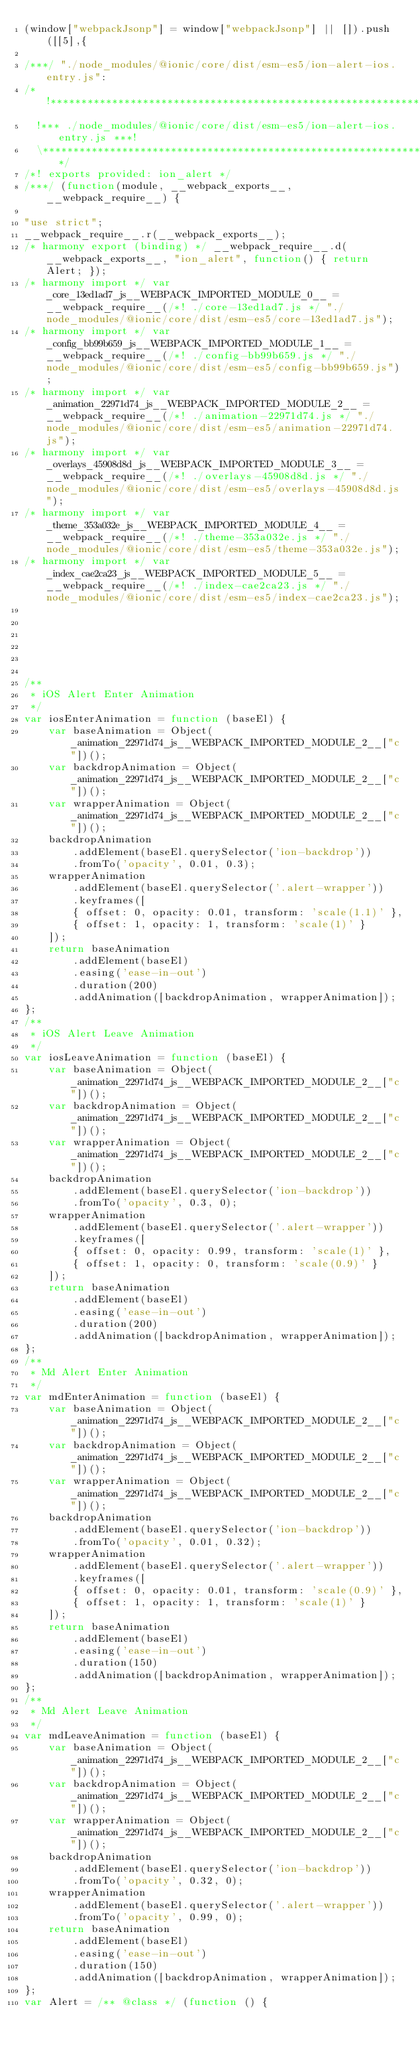<code> <loc_0><loc_0><loc_500><loc_500><_JavaScript_>(window["webpackJsonp"] = window["webpackJsonp"] || []).push([[5],{

/***/ "./node_modules/@ionic/core/dist/esm-es5/ion-alert-ios.entry.js":
/*!**********************************************************************!*\
  !*** ./node_modules/@ionic/core/dist/esm-es5/ion-alert-ios.entry.js ***!
  \**********************************************************************/
/*! exports provided: ion_alert */
/***/ (function(module, __webpack_exports__, __webpack_require__) {

"use strict";
__webpack_require__.r(__webpack_exports__);
/* harmony export (binding) */ __webpack_require__.d(__webpack_exports__, "ion_alert", function() { return Alert; });
/* harmony import */ var _core_13ed1ad7_js__WEBPACK_IMPORTED_MODULE_0__ = __webpack_require__(/*! ./core-13ed1ad7.js */ "./node_modules/@ionic/core/dist/esm-es5/core-13ed1ad7.js");
/* harmony import */ var _config_bb99b659_js__WEBPACK_IMPORTED_MODULE_1__ = __webpack_require__(/*! ./config-bb99b659.js */ "./node_modules/@ionic/core/dist/esm-es5/config-bb99b659.js");
/* harmony import */ var _animation_22971d74_js__WEBPACK_IMPORTED_MODULE_2__ = __webpack_require__(/*! ./animation-22971d74.js */ "./node_modules/@ionic/core/dist/esm-es5/animation-22971d74.js");
/* harmony import */ var _overlays_45908d8d_js__WEBPACK_IMPORTED_MODULE_3__ = __webpack_require__(/*! ./overlays-45908d8d.js */ "./node_modules/@ionic/core/dist/esm-es5/overlays-45908d8d.js");
/* harmony import */ var _theme_353a032e_js__WEBPACK_IMPORTED_MODULE_4__ = __webpack_require__(/*! ./theme-353a032e.js */ "./node_modules/@ionic/core/dist/esm-es5/theme-353a032e.js");
/* harmony import */ var _index_cae2ca23_js__WEBPACK_IMPORTED_MODULE_5__ = __webpack_require__(/*! ./index-cae2ca23.js */ "./node_modules/@ionic/core/dist/esm-es5/index-cae2ca23.js");






/**
 * iOS Alert Enter Animation
 */
var iosEnterAnimation = function (baseEl) {
    var baseAnimation = Object(_animation_22971d74_js__WEBPACK_IMPORTED_MODULE_2__["c"])();
    var backdropAnimation = Object(_animation_22971d74_js__WEBPACK_IMPORTED_MODULE_2__["c"])();
    var wrapperAnimation = Object(_animation_22971d74_js__WEBPACK_IMPORTED_MODULE_2__["c"])();
    backdropAnimation
        .addElement(baseEl.querySelector('ion-backdrop'))
        .fromTo('opacity', 0.01, 0.3);
    wrapperAnimation
        .addElement(baseEl.querySelector('.alert-wrapper'))
        .keyframes([
        { offset: 0, opacity: 0.01, transform: 'scale(1.1)' },
        { offset: 1, opacity: 1, transform: 'scale(1)' }
    ]);
    return baseAnimation
        .addElement(baseEl)
        .easing('ease-in-out')
        .duration(200)
        .addAnimation([backdropAnimation, wrapperAnimation]);
};
/**
 * iOS Alert Leave Animation
 */
var iosLeaveAnimation = function (baseEl) {
    var baseAnimation = Object(_animation_22971d74_js__WEBPACK_IMPORTED_MODULE_2__["c"])();
    var backdropAnimation = Object(_animation_22971d74_js__WEBPACK_IMPORTED_MODULE_2__["c"])();
    var wrapperAnimation = Object(_animation_22971d74_js__WEBPACK_IMPORTED_MODULE_2__["c"])();
    backdropAnimation
        .addElement(baseEl.querySelector('ion-backdrop'))
        .fromTo('opacity', 0.3, 0);
    wrapperAnimation
        .addElement(baseEl.querySelector('.alert-wrapper'))
        .keyframes([
        { offset: 0, opacity: 0.99, transform: 'scale(1)' },
        { offset: 1, opacity: 0, transform: 'scale(0.9)' }
    ]);
    return baseAnimation
        .addElement(baseEl)
        .easing('ease-in-out')
        .duration(200)
        .addAnimation([backdropAnimation, wrapperAnimation]);
};
/**
 * Md Alert Enter Animation
 */
var mdEnterAnimation = function (baseEl) {
    var baseAnimation = Object(_animation_22971d74_js__WEBPACK_IMPORTED_MODULE_2__["c"])();
    var backdropAnimation = Object(_animation_22971d74_js__WEBPACK_IMPORTED_MODULE_2__["c"])();
    var wrapperAnimation = Object(_animation_22971d74_js__WEBPACK_IMPORTED_MODULE_2__["c"])();
    backdropAnimation
        .addElement(baseEl.querySelector('ion-backdrop'))
        .fromTo('opacity', 0.01, 0.32);
    wrapperAnimation
        .addElement(baseEl.querySelector('.alert-wrapper'))
        .keyframes([
        { offset: 0, opacity: 0.01, transform: 'scale(0.9)' },
        { offset: 1, opacity: 1, transform: 'scale(1)' }
    ]);
    return baseAnimation
        .addElement(baseEl)
        .easing('ease-in-out')
        .duration(150)
        .addAnimation([backdropAnimation, wrapperAnimation]);
};
/**
 * Md Alert Leave Animation
 */
var mdLeaveAnimation = function (baseEl) {
    var baseAnimation = Object(_animation_22971d74_js__WEBPACK_IMPORTED_MODULE_2__["c"])();
    var backdropAnimation = Object(_animation_22971d74_js__WEBPACK_IMPORTED_MODULE_2__["c"])();
    var wrapperAnimation = Object(_animation_22971d74_js__WEBPACK_IMPORTED_MODULE_2__["c"])();
    backdropAnimation
        .addElement(baseEl.querySelector('ion-backdrop'))
        .fromTo('opacity', 0.32, 0);
    wrapperAnimation
        .addElement(baseEl.querySelector('.alert-wrapper'))
        .fromTo('opacity', 0.99, 0);
    return baseAnimation
        .addElement(baseEl)
        .easing('ease-in-out')
        .duration(150)
        .addAnimation([backdropAnimation, wrapperAnimation]);
};
var Alert = /** @class */ (function () {</code> 